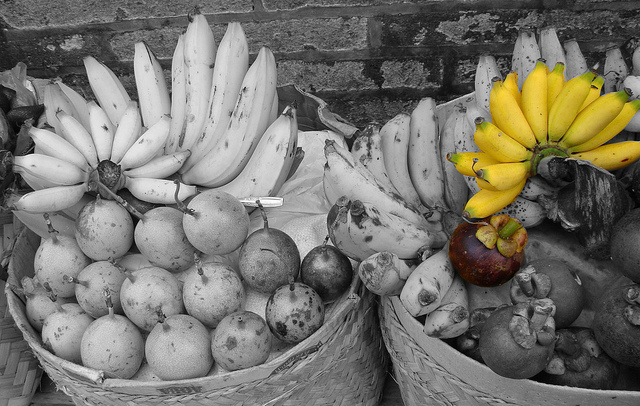Imagine this scene is taking place on an alien planet. Describe the setup and what might be happening. On the alien planet of Banaria, the residents proudly display their harvest in large, woven baskets. The left basket, brimming with monochromatic alien bananas and fruits, represents their agricultural history preserved in tradition. The right basket, with its vibrant yellow bananas, symbolizes the new age of genetic enhancements that they celebrate. Aliens gather around to exchange their heritage and advancements, making this scene a hub of cultural and scientific fusion. 